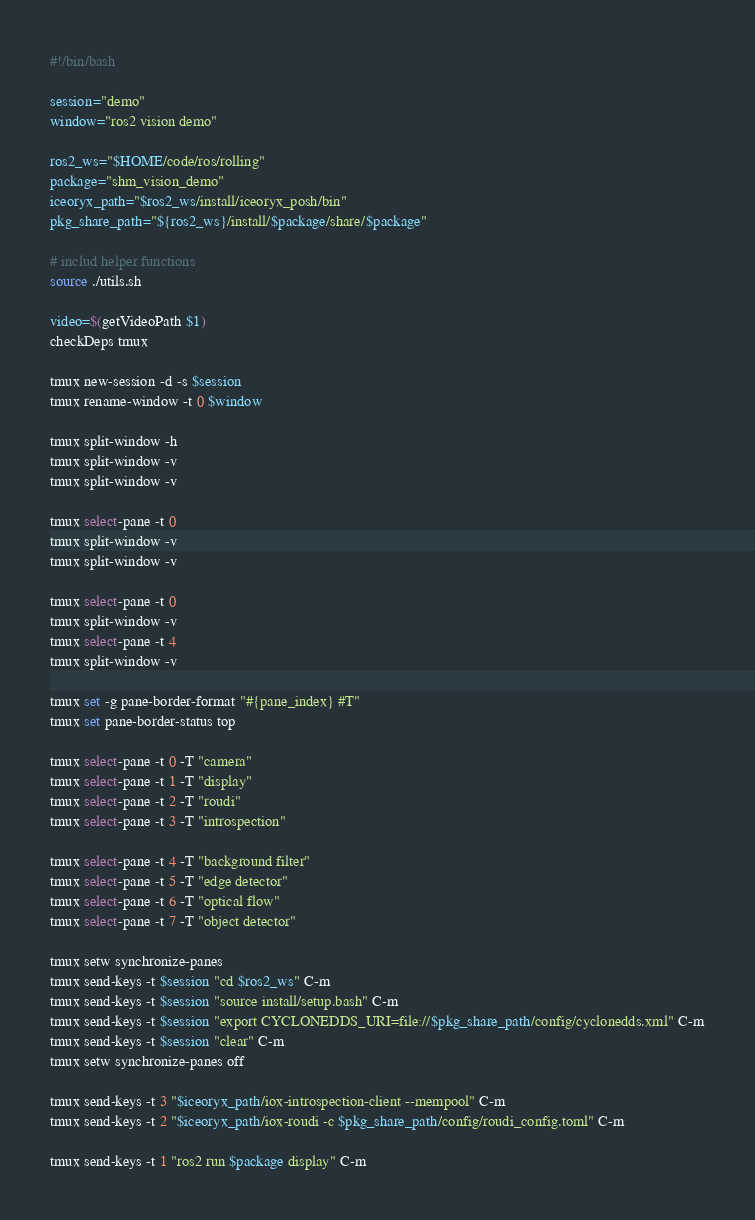<code> <loc_0><loc_0><loc_500><loc_500><_Bash_>#!/bin/bash

session="demo"
window="ros2 vision demo"

ros2_ws="$HOME/code/ros/rolling"
package="shm_vision_demo"
iceoryx_path="$ros2_ws/install/iceoryx_posh/bin"
pkg_share_path="${ros2_ws}/install/$package/share/$package"

# includ helper functions
source ./utils.sh

video=$(getVideoPath $1)
checkDeps tmux

tmux new-session -d -s $session
tmux rename-window -t 0 $window

tmux split-window -h
tmux split-window -v
tmux split-window -v

tmux select-pane -t 0
tmux split-window -v
tmux split-window -v

tmux select-pane -t 0
tmux split-window -v
tmux select-pane -t 4
tmux split-window -v

tmux set -g pane-border-format "#{pane_index} #T"
tmux set pane-border-status top

tmux select-pane -t 0 -T "camera"
tmux select-pane -t 1 -T "display"
tmux select-pane -t 2 -T "roudi"
tmux select-pane -t 3 -T "introspection"

tmux select-pane -t 4 -T "background filter"
tmux select-pane -t 5 -T "edge detector"
tmux select-pane -t 6 -T "optical flow"
tmux select-pane -t 7 -T "object detector"

tmux setw synchronize-panes
tmux send-keys -t $session "cd $ros2_ws" C-m
tmux send-keys -t $session "source install/setup.bash" C-m
tmux send-keys -t $session "export CYCLONEDDS_URI=file://$pkg_share_path/config/cyclonedds.xml" C-m
tmux send-keys -t $session "clear" C-m
tmux setw synchronize-panes off

tmux send-keys -t 3 "$iceoryx_path/iox-introspection-client --mempool" C-m
tmux send-keys -t 2 "$iceoryx_path/iox-roudi -c $pkg_share_path/config/roudi_config.toml" C-m

tmux send-keys -t 1 "ros2 run $package display" C-m
</code> 